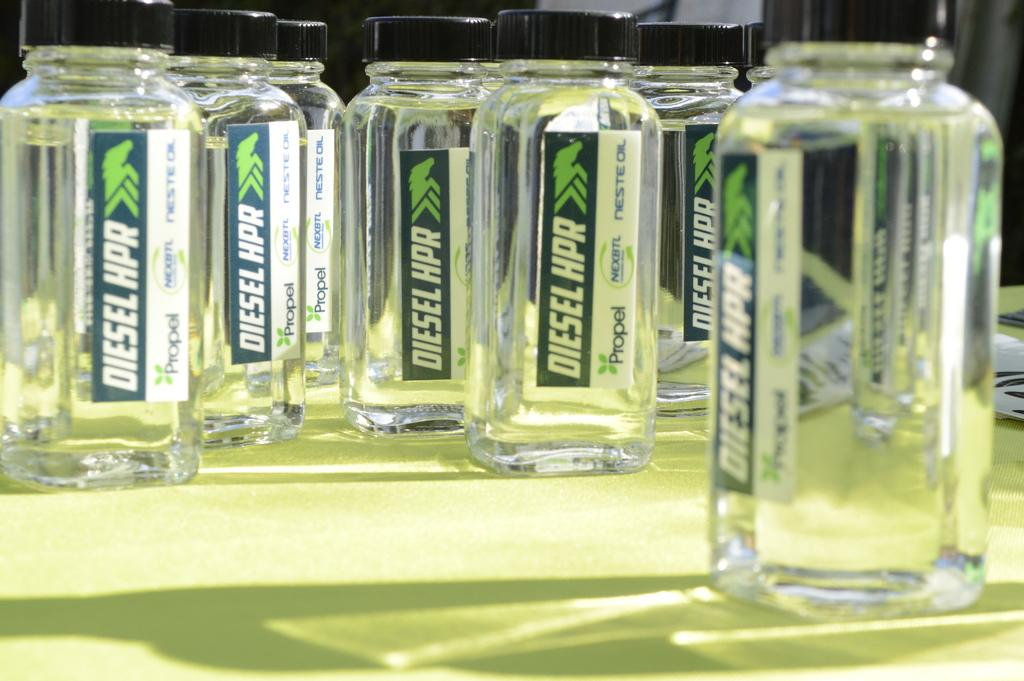<image>
Share a concise interpretation of the image provided. the word diesel is on the clear jar 